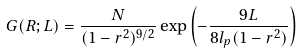Convert formula to latex. <formula><loc_0><loc_0><loc_500><loc_500>G ( R ; L ) = \frac { N } { ( 1 - r ^ { 2 } ) ^ { 9 / 2 } } \exp \left ( - \frac { 9 L } { 8 l _ { p } ( 1 - r ^ { 2 } ) } \right )</formula> 